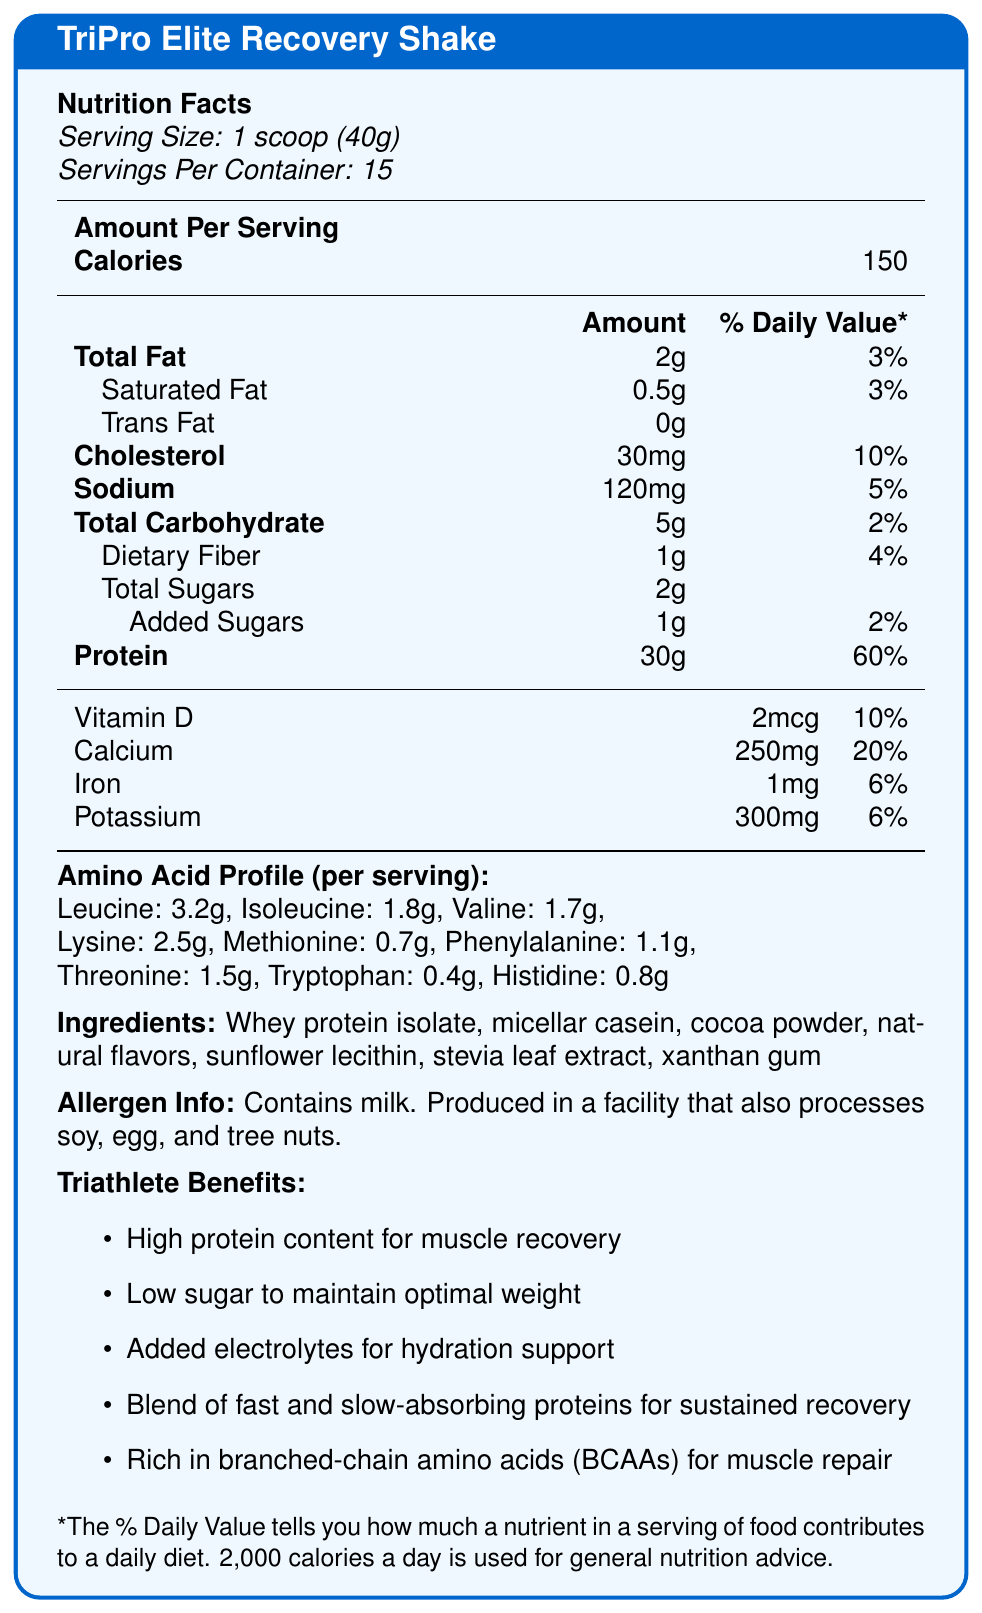What is the serving size for the TriPro Elite Recovery Shake? The document specifies that the serving size is 1 scoop which weighs 40 grams.
Answer: 1 scoop (40g) How many servings are there per container? The document states that there are 15 servings per container.
Answer: 15 How many total calories are in one serving? The Nutrition Facts section of the document lists the calories per serving as 150.
Answer: 150 What is the amount of protein per serving? The document highlights that each serving contains 30 grams of protein.
Answer: 30g What two types of proteins are included in the ingredients? The ingredients listed in the document are whey protein isolate and micellar casein, among other components.
Answer: Whey protein isolate and micellar casein Which amino acid has the highest amount per serving in the shake? A. Leucine B. Lysine C. Valine D. Isoleucine The document states that the leucine content per serving is 3.2 grams, which is higher than the amounts for lysine (2.5g), valine (1.7g), and isoleucine (1.8g).
Answer: A. Leucine How much total fat is in one serving of the shake? A. 1g B. 2g C. 3g D. 4g The Nutrition Facts section lists the total fat per serving as 2 grams.
Answer: B. 2g Is this product suitable for someone with a nut allergy? The allergen info indicates that the product is produced in a facility that processes tree nuts, which may pose a risk.
Answer: No Summarize the main benefits of the TriPro Elite Recovery Shake for triathletes. The document outlines these benefits specifically for triathletes, focusing on muscle recovery, weight maintenance, hydration, protein absorption, and amino acids.
Answer: High protein content for muscle recovery, low sugar to maintain optimal weight, added electrolytes for hydration support, blend of fast and slow-absorbing proteins for sustained recovery, and rich in BCAAs for muscle repair. What is the primary function of the electrolytes added to the shake? One of the listed benefits for triathletes states that added electrolytes are included for hydration support.
Answer: Hydration support How much added sugar is in each serving? The document lists the amount of added sugars as 1 gram per serving.
Answer: 1g What is the total carbohydrate content in one serving of the recovery shake? The Nutrition Facts section specifies that the total carbohydrate content is 5 grams per serving.
Answer: 5g Which of the following is not an ingredient in the TriPro Elite Recovery Shake? A. Cocoa powder B. Natural flavors C. Whole milk D. Sunflower lecithin The ingredients do not include whole milk but do include cocoa powder, natural flavors, and sunflower lecithin.
Answer: C. Whole milk Can we determine the price of the product from the document? The document does not provide any information regarding the price of the product.
Answer: Cannot be determined 